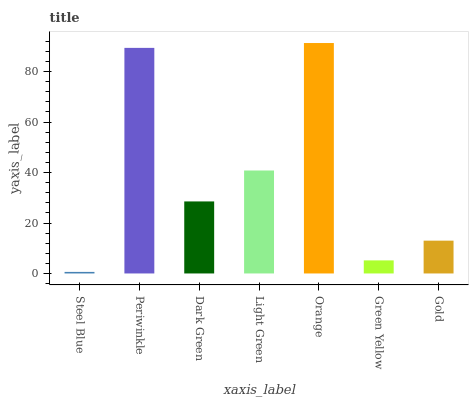Is Steel Blue the minimum?
Answer yes or no. Yes. Is Orange the maximum?
Answer yes or no. Yes. Is Periwinkle the minimum?
Answer yes or no. No. Is Periwinkle the maximum?
Answer yes or no. No. Is Periwinkle greater than Steel Blue?
Answer yes or no. Yes. Is Steel Blue less than Periwinkle?
Answer yes or no. Yes. Is Steel Blue greater than Periwinkle?
Answer yes or no. No. Is Periwinkle less than Steel Blue?
Answer yes or no. No. Is Dark Green the high median?
Answer yes or no. Yes. Is Dark Green the low median?
Answer yes or no. Yes. Is Light Green the high median?
Answer yes or no. No. Is Periwinkle the low median?
Answer yes or no. No. 